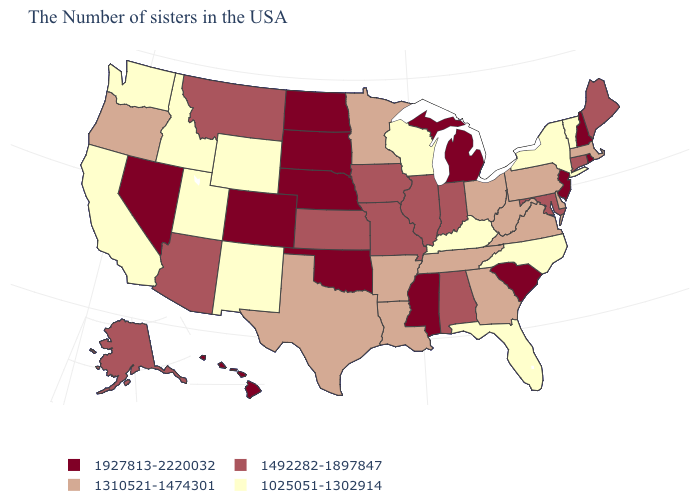Does Arizona have a higher value than Massachusetts?
Answer briefly. Yes. Name the states that have a value in the range 1025051-1302914?
Write a very short answer. Vermont, New York, North Carolina, Florida, Kentucky, Wisconsin, Wyoming, New Mexico, Utah, Idaho, California, Washington. What is the value of Georgia?
Give a very brief answer. 1310521-1474301. Among the states that border Pennsylvania , which have the lowest value?
Keep it brief. New York. What is the lowest value in the Northeast?
Answer briefly. 1025051-1302914. What is the value of Hawaii?
Give a very brief answer. 1927813-2220032. Name the states that have a value in the range 1492282-1897847?
Give a very brief answer. Maine, Connecticut, Maryland, Indiana, Alabama, Illinois, Missouri, Iowa, Kansas, Montana, Arizona, Alaska. What is the highest value in the USA?
Keep it brief. 1927813-2220032. Does Delaware have a lower value than California?
Write a very short answer. No. Does Kentucky have the highest value in the USA?
Short answer required. No. What is the value of Tennessee?
Quick response, please. 1310521-1474301. What is the lowest value in the USA?
Concise answer only. 1025051-1302914. Which states have the highest value in the USA?
Short answer required. Rhode Island, New Hampshire, New Jersey, South Carolina, Michigan, Mississippi, Nebraska, Oklahoma, South Dakota, North Dakota, Colorado, Nevada, Hawaii. Which states have the lowest value in the USA?
Concise answer only. Vermont, New York, North Carolina, Florida, Kentucky, Wisconsin, Wyoming, New Mexico, Utah, Idaho, California, Washington. Does Wisconsin have the highest value in the MidWest?
Write a very short answer. No. 